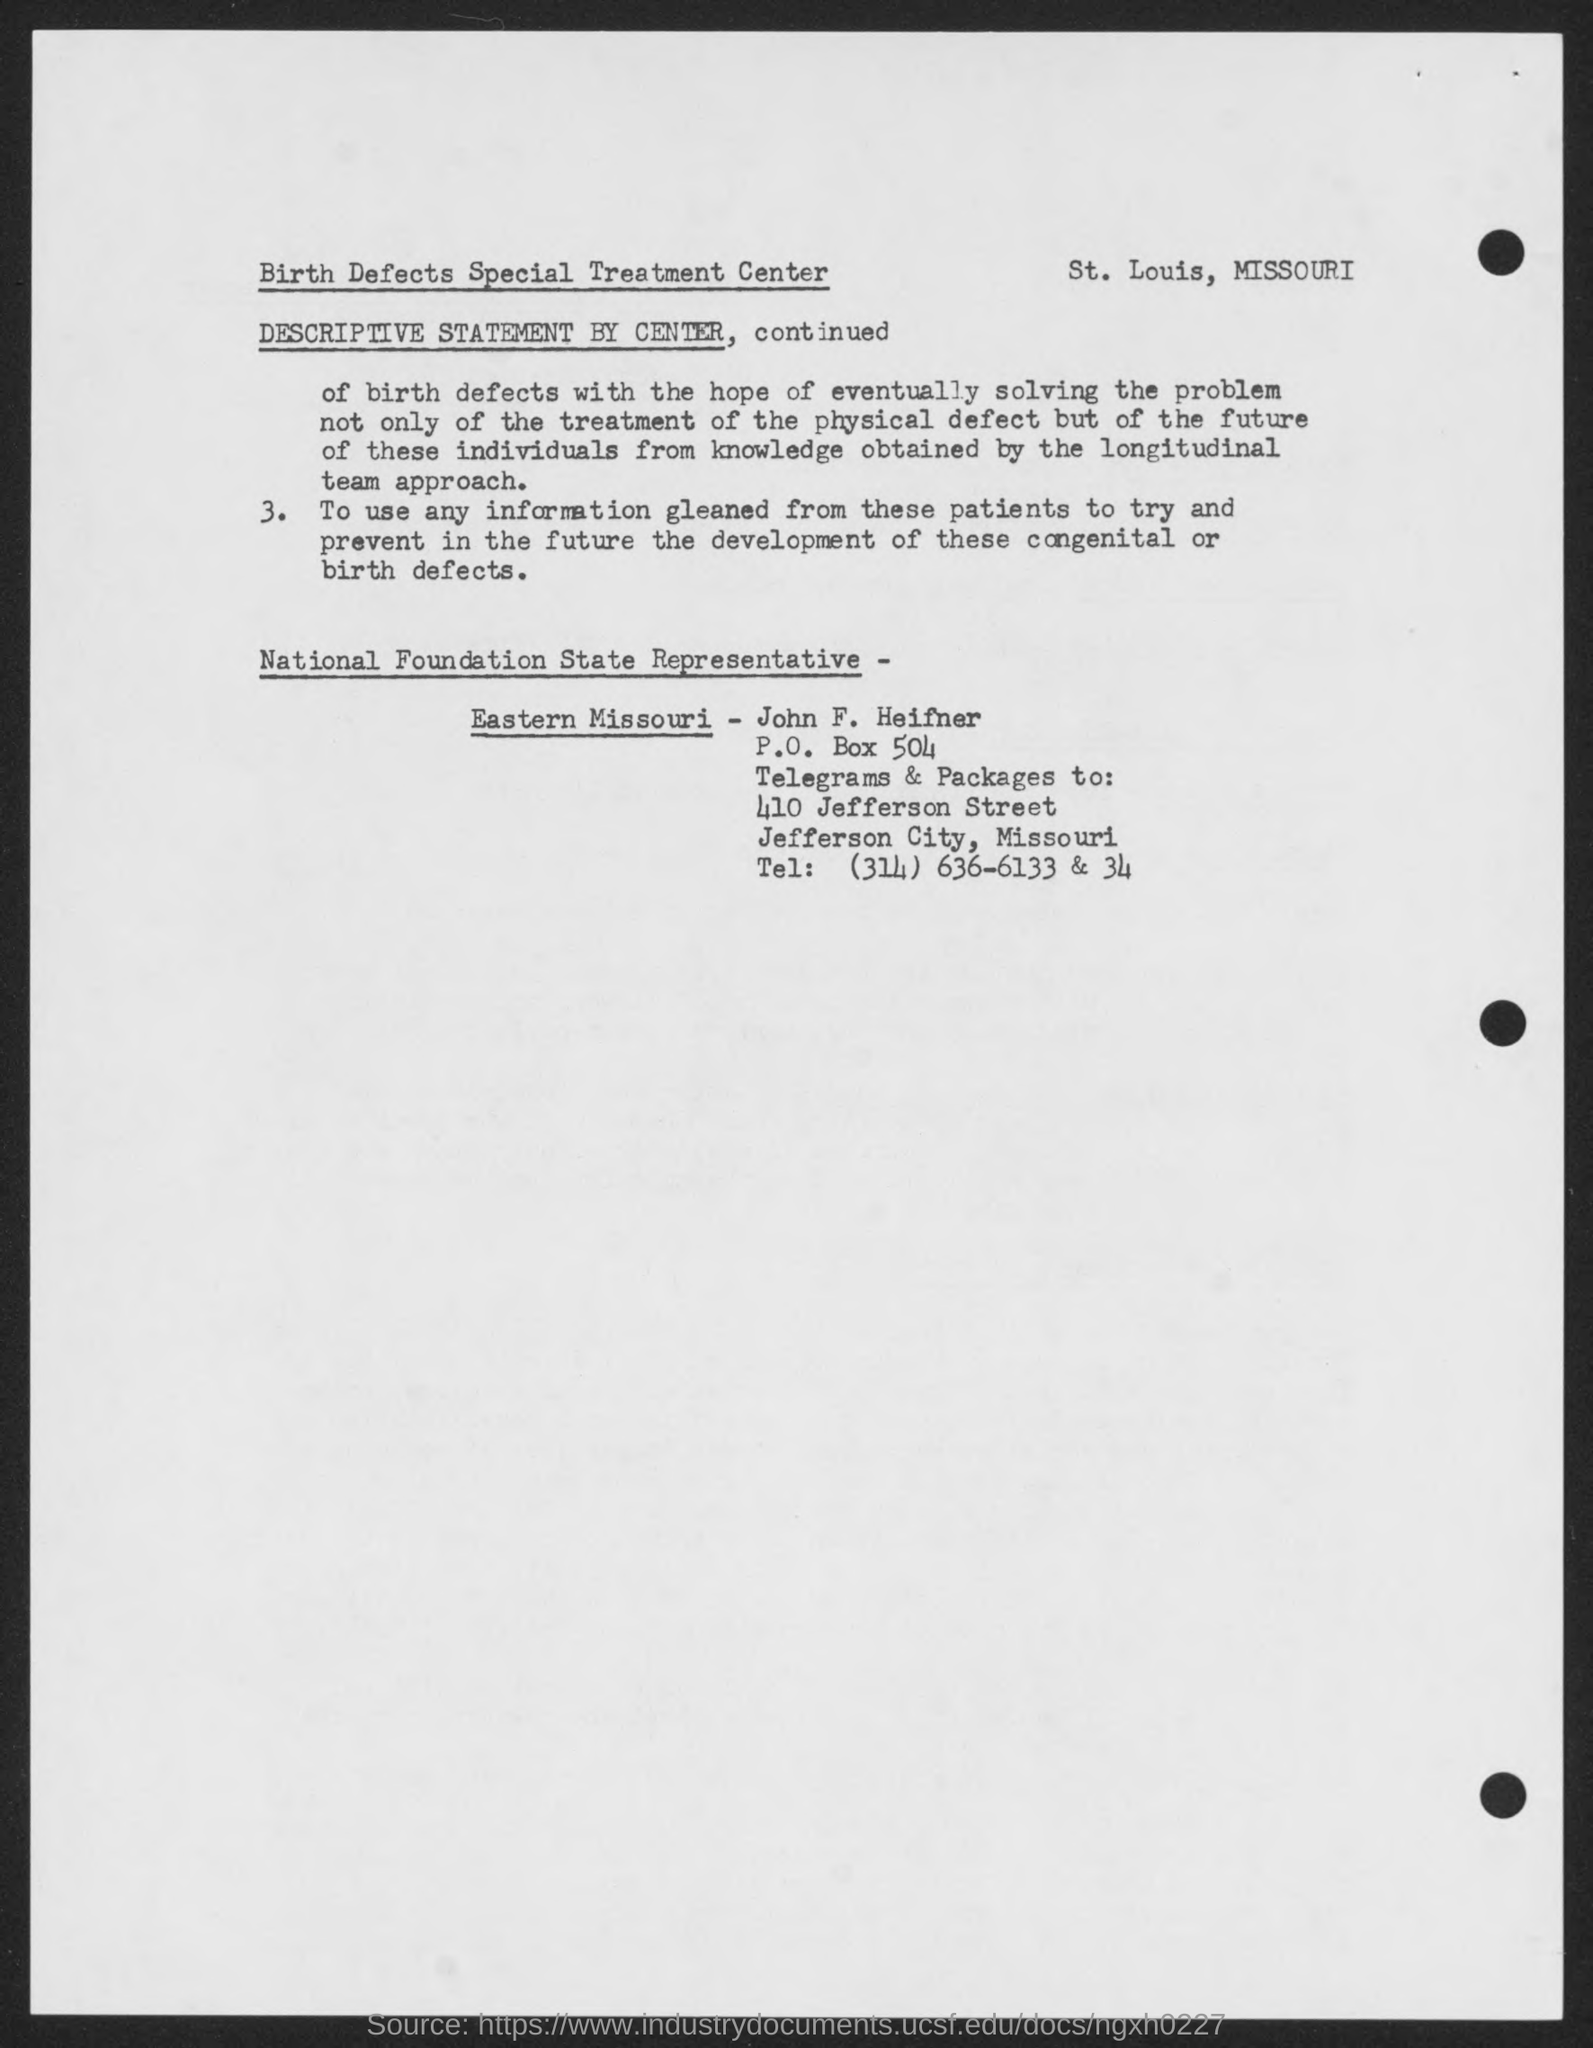Who is the National Foundation State Representative-Eastern Missouri?
Offer a very short reply. John F. Heifner. What is the P. O. Box no given in the address?
Your answer should be compact. 504. What is the Tel no mentioned in the document?
Ensure brevity in your answer.  (314) 636-6133 & 34. 